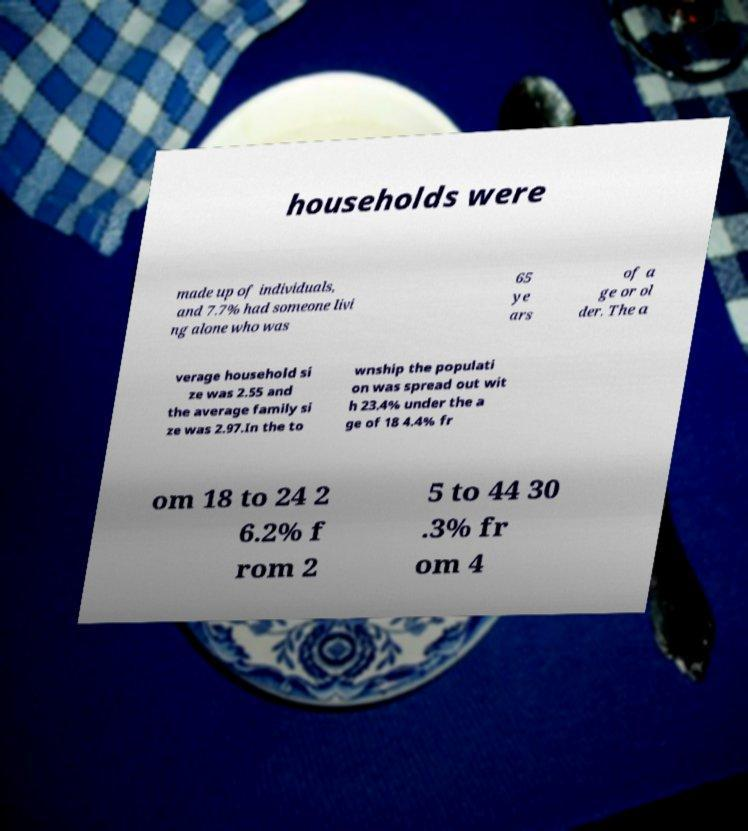Please identify and transcribe the text found in this image. households were made up of individuals, and 7.7% had someone livi ng alone who was 65 ye ars of a ge or ol der. The a verage household si ze was 2.55 and the average family si ze was 2.97.In the to wnship the populati on was spread out wit h 23.4% under the a ge of 18 4.4% fr om 18 to 24 2 6.2% f rom 2 5 to 44 30 .3% fr om 4 